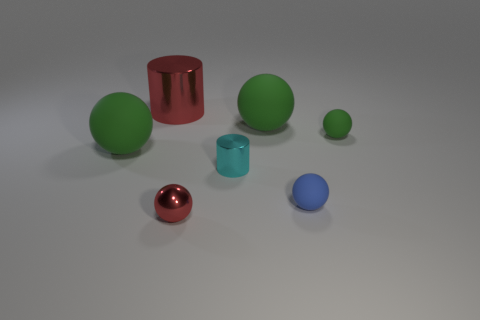What color is the small cylinder?
Your answer should be very brief. Cyan. What material is the sphere in front of the blue rubber thing?
Ensure brevity in your answer.  Metal. Is the number of green rubber objects in front of the small blue rubber sphere the same as the number of small blue blocks?
Ensure brevity in your answer.  Yes. Does the small red thing have the same shape as the small green object?
Provide a succinct answer. Yes. Are there any other things that are the same color as the small cylinder?
Offer a very short reply. No. There is a shiny object that is behind the red metal ball and in front of the tiny green rubber thing; what shape is it?
Your response must be concise. Cylinder. Is the number of cylinders in front of the tiny green matte object the same as the number of rubber balls in front of the small blue sphere?
Make the answer very short. No. How many cylinders are either large objects or tiny objects?
Make the answer very short. 2. What number of small green things are the same material as the big red thing?
Ensure brevity in your answer.  0. The tiny metal thing that is the same color as the big shiny cylinder is what shape?
Provide a succinct answer. Sphere. 